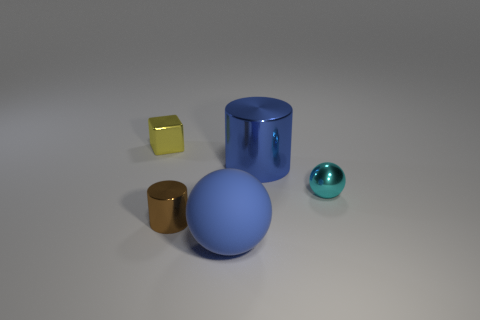If the blue sphere were to roll away, what direction would it go based on the surface? Given the flat appearance of the surface in the image, if unobstructed, the blue sphere could roll in any direction, as there seems to be no incline to dictate its movement. 